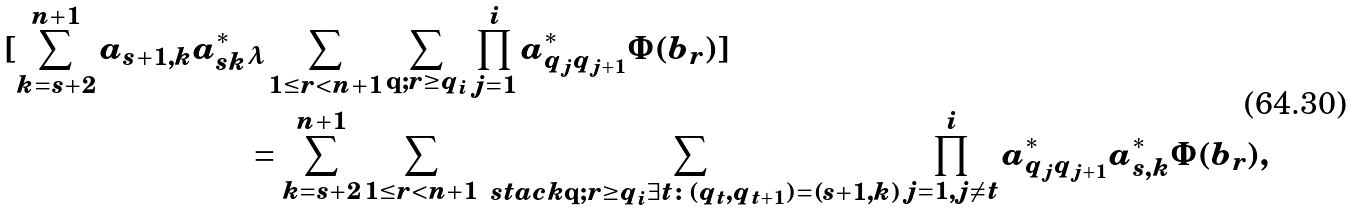Convert formula to latex. <formula><loc_0><loc_0><loc_500><loc_500>[ \sum _ { k = s + 2 } ^ { n + 1 } a _ { s + 1 , k } a _ { s k } ^ { * } & { _ { \boldsymbol \lambda } } \sum _ { 1 \leq r < n + 1 } \sum _ { \mathbf q ; r \geq q _ { i } } \prod _ { j = 1 } ^ { i } a _ { q _ { j } q { _ { j + 1 } } } ^ { * } \Phi ( b _ { r } ) ] \\ & = \sum _ { k = s + 2 } ^ { n + 1 } \sum _ { 1 \leq r < n + 1 } \sum _ { \ s t a c k { \mathbf q ; r \geq q _ { i } } { \exists t \colon ( q _ { t } , q _ { t + 1 } ) = ( s + 1 , k ) } } \prod _ { j = 1 , j \neq t } ^ { i } a _ { q _ { j } q { _ { j + 1 } } } ^ { * } a _ { s , k } ^ { * } \Phi ( b _ { r } ) ,</formula> 